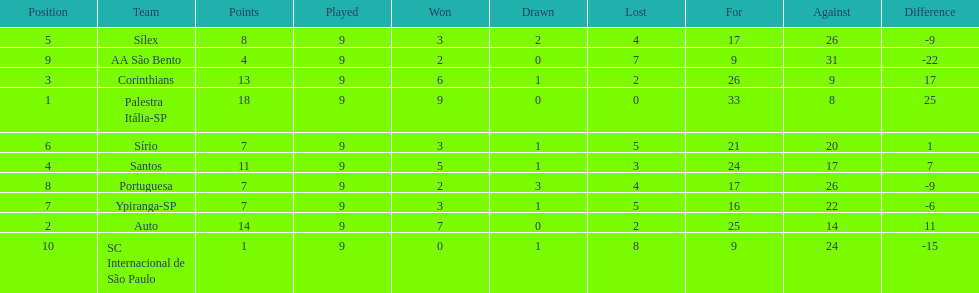Which brazilian team took the top spot in the 1926 brazilian football cup? Palestra Itália-SP. 